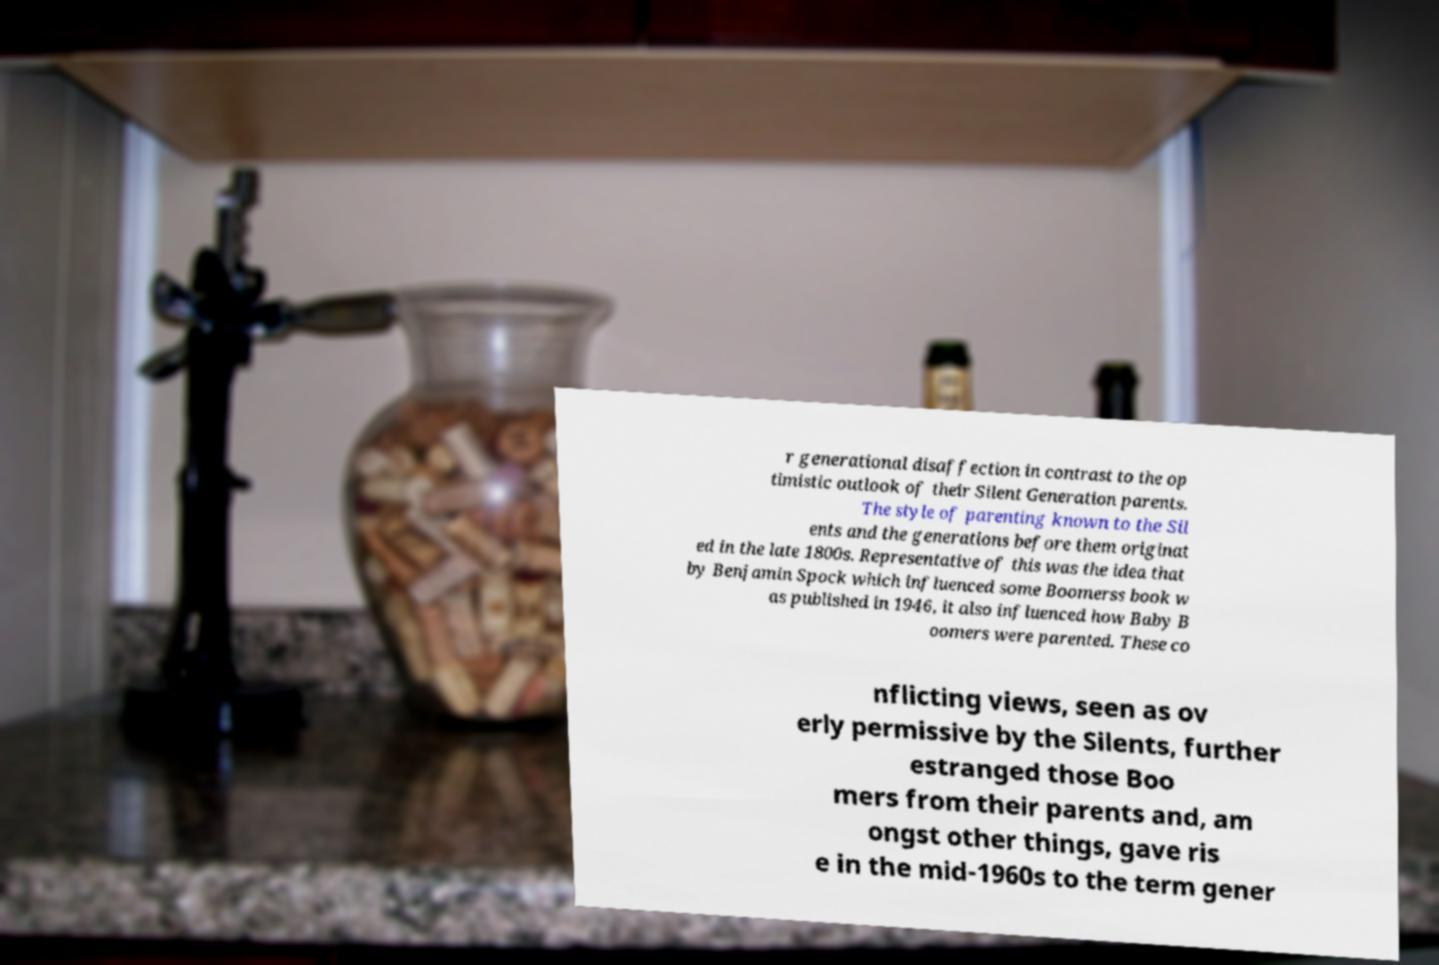Please identify and transcribe the text found in this image. r generational disaffection in contrast to the op timistic outlook of their Silent Generation parents. The style of parenting known to the Sil ents and the generations before them originat ed in the late 1800s. Representative of this was the idea that by Benjamin Spock which influenced some Boomerss book w as published in 1946, it also influenced how Baby B oomers were parented. These co nflicting views, seen as ov erly permissive by the Silents, further estranged those Boo mers from their parents and, am ongst other things, gave ris e in the mid-1960s to the term gener 